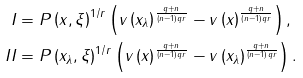<formula> <loc_0><loc_0><loc_500><loc_500>I & = P \left ( x , \xi \right ) ^ { 1 / r } \left ( v \left ( x _ { \lambda } \right ) ^ { \frac { q + n } { \left ( n - 1 \right ) q r } } - v \left ( x \right ) ^ { \frac { q + n } { \left ( n - 1 \right ) q r } } \right ) , \\ I I & = P \left ( x _ { \lambda } , \xi \right ) ^ { 1 / r } \left ( v \left ( x \right ) ^ { \frac { q + n } { \left ( n - 1 \right ) q r } } - v \left ( x _ { \lambda } \right ) ^ { \frac { q + n } { \left ( n - 1 \right ) q r } } \right ) .</formula> 